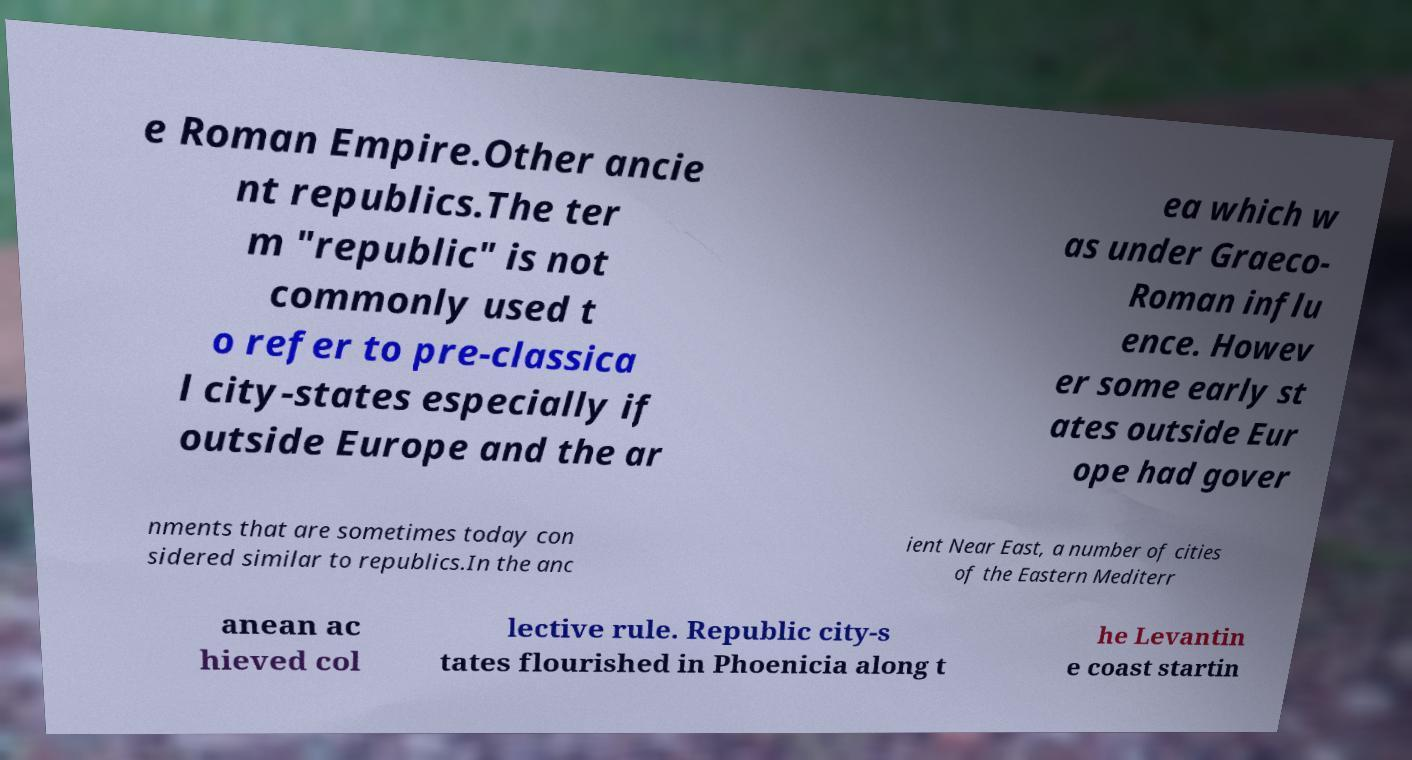Please identify and transcribe the text found in this image. e Roman Empire.Other ancie nt republics.The ter m "republic" is not commonly used t o refer to pre-classica l city-states especially if outside Europe and the ar ea which w as under Graeco- Roman influ ence. Howev er some early st ates outside Eur ope had gover nments that are sometimes today con sidered similar to republics.In the anc ient Near East, a number of cities of the Eastern Mediterr anean ac hieved col lective rule. Republic city-s tates flourished in Phoenicia along t he Levantin e coast startin 